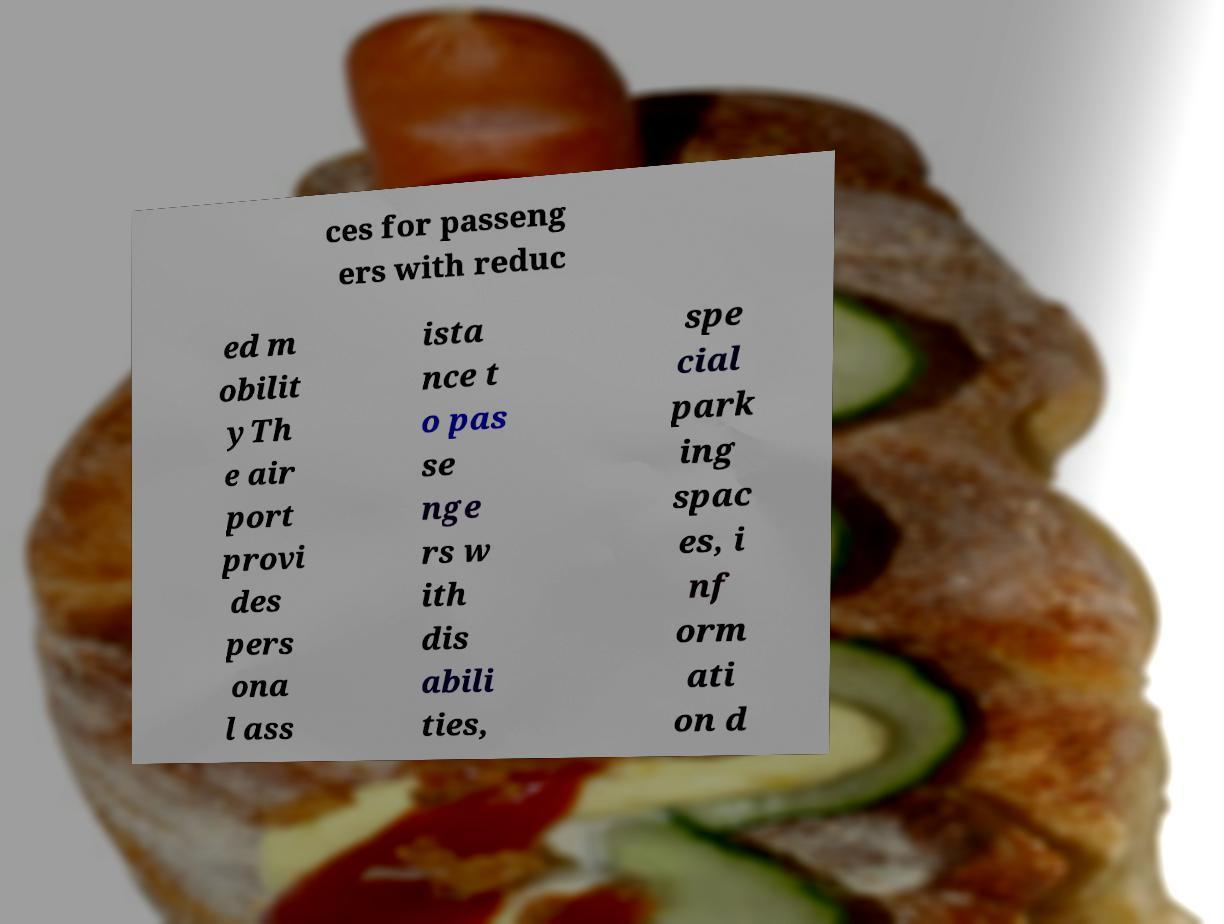I need the written content from this picture converted into text. Can you do that? ces for passeng ers with reduc ed m obilit yTh e air port provi des pers ona l ass ista nce t o pas se nge rs w ith dis abili ties, spe cial park ing spac es, i nf orm ati on d 